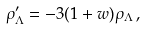<formula> <loc_0><loc_0><loc_500><loc_500>\rho _ { \Lambda } ^ { \prime } = - 3 ( 1 + w ) \rho _ { \Lambda } \, ,</formula> 